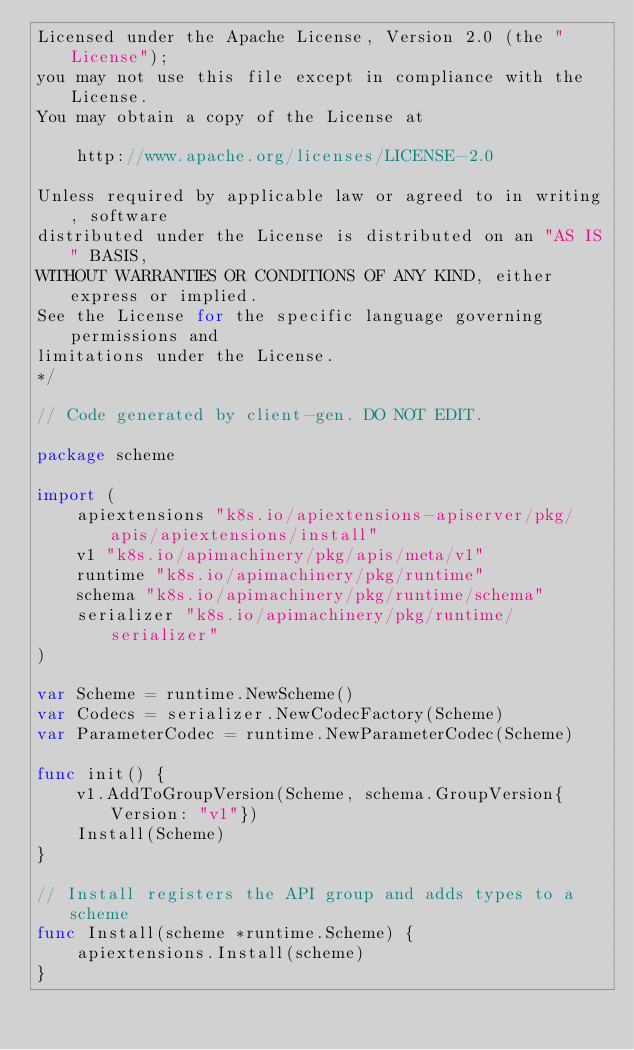<code> <loc_0><loc_0><loc_500><loc_500><_Go_>Licensed under the Apache License, Version 2.0 (the "License");
you may not use this file except in compliance with the License.
You may obtain a copy of the License at

    http://www.apache.org/licenses/LICENSE-2.0

Unless required by applicable law or agreed to in writing, software
distributed under the License is distributed on an "AS IS" BASIS,
WITHOUT WARRANTIES OR CONDITIONS OF ANY KIND, either express or implied.
See the License for the specific language governing permissions and
limitations under the License.
*/

// Code generated by client-gen. DO NOT EDIT.

package scheme

import (
	apiextensions "k8s.io/apiextensions-apiserver/pkg/apis/apiextensions/install"
	v1 "k8s.io/apimachinery/pkg/apis/meta/v1"
	runtime "k8s.io/apimachinery/pkg/runtime"
	schema "k8s.io/apimachinery/pkg/runtime/schema"
	serializer "k8s.io/apimachinery/pkg/runtime/serializer"
)

var Scheme = runtime.NewScheme()
var Codecs = serializer.NewCodecFactory(Scheme)
var ParameterCodec = runtime.NewParameterCodec(Scheme)

func init() {
	v1.AddToGroupVersion(Scheme, schema.GroupVersion{Version: "v1"})
	Install(Scheme)
}

// Install registers the API group and adds types to a scheme
func Install(scheme *runtime.Scheme) {
	apiextensions.Install(scheme)
}
</code> 